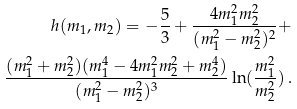<formula> <loc_0><loc_0><loc_500><loc_500>h ( m _ { 1 } , m _ { 2 } ) = - \frac { 5 } { 3 } + \frac { 4 m _ { 1 } ^ { 2 } m _ { 2 } ^ { 2 } } { ( m _ { 1 } ^ { 2 } - m _ { 2 } ^ { 2 } ) ^ { 2 } } + \\ \frac { ( m _ { 1 } ^ { 2 } + m _ { 2 } ^ { 2 } ) ( m _ { 1 } ^ { 4 } - 4 m _ { 1 } ^ { 2 } m _ { 2 } ^ { 2 } + m _ { 2 } ^ { 4 } ) } { ( m _ { 1 } ^ { 2 } - m _ { 2 } ^ { 2 } ) ^ { 3 } } \ln ( \frac { m _ { 1 } ^ { 2 } } { m _ { 2 } ^ { 2 } } ) \, .</formula> 